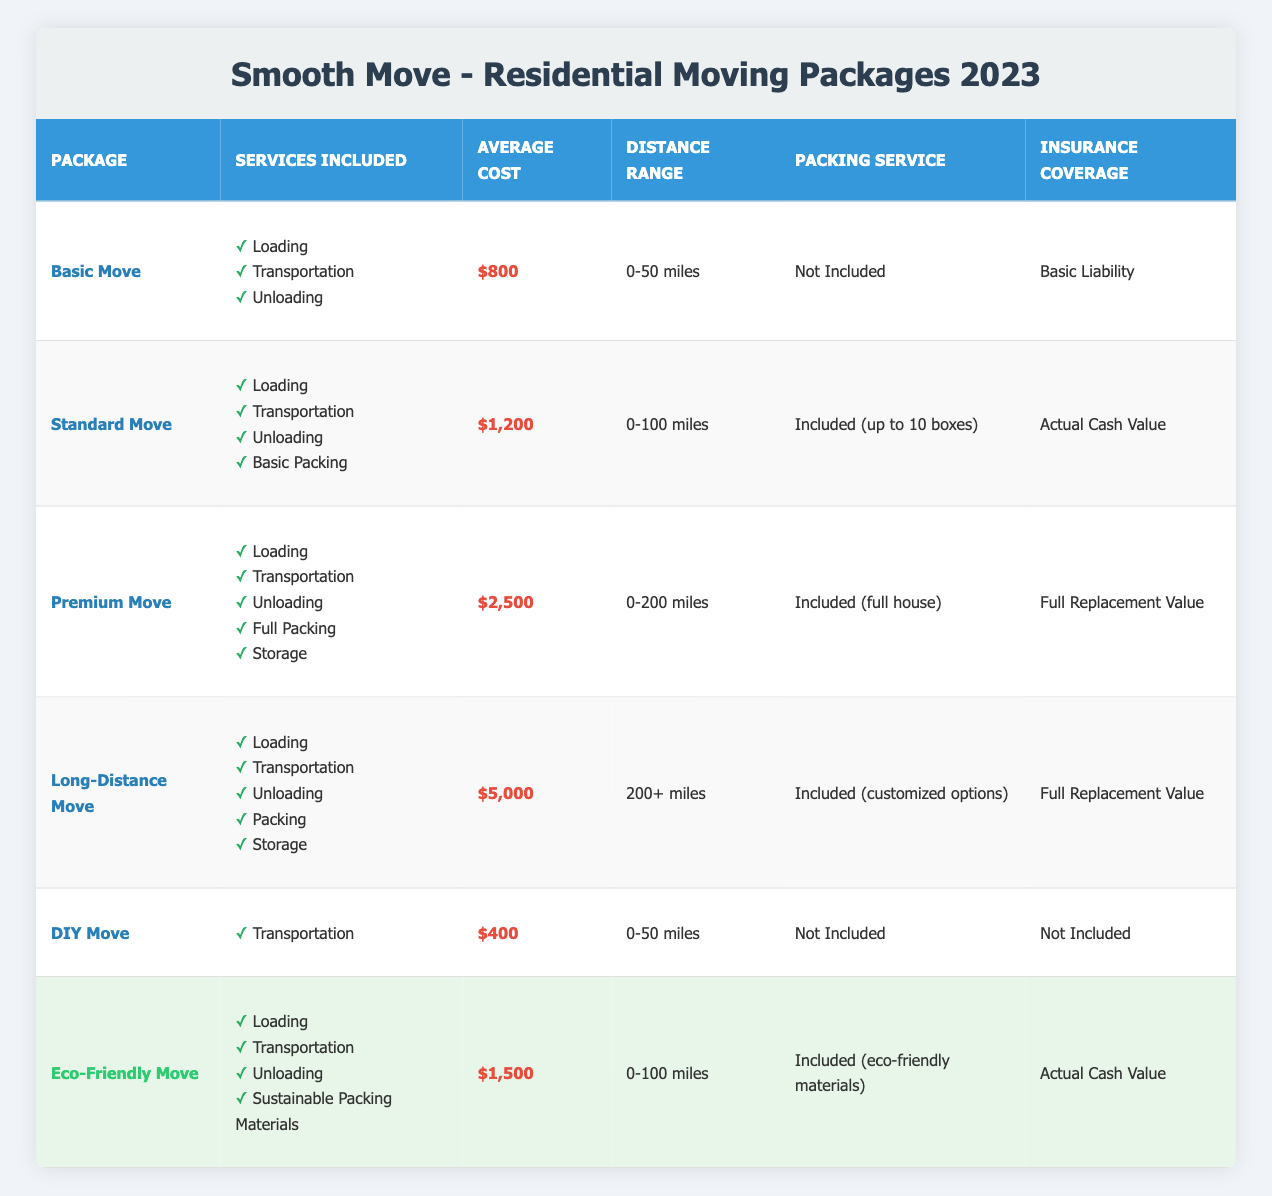What is the average cost of the Standard Move package? The average cost of the Standard Move package is listed in the table as $1,200.
Answer: $1,200 Which package offers full packing service? The Premium Move and Long-Distance Move packages both include full packing service, as indicated in the table.
Answer: Premium Move and Long-Distance Move Is insurance coverage included in the DIY Move package? The table specifies that the DIY Move package does not include any insurance coverage.
Answer: No What services are included in the Eco-Friendly Move package? The services included in the Eco-Friendly Move package are Loading, Transportation, Unloading, and Sustainable Packing Materials, as shown in the table.
Answer: Loading, Transportation, Unloading, Sustainable Packing Materials If a customer needs to move over 200 miles, which package is available? The only package available for a distance over 200 miles is the Long-Distance Move package, according to the distance range specified in the table.
Answer: Long-Distance Move How many packages include packing services? The packages that include packing services are Standard Move, Premium Move, Long-Distance Move, and Eco-Friendly Move. There are four such packages in total.
Answer: 4 What is the total average cost of the Basic Move and DIY Move packages? To find the total average cost of the Basic Move and DIY Move packages, add their average costs: $800 (Basic Move) + $400 (DIY Move) = $1,200. Therefore, the total average cost is $1,200.
Answer: $1,200 Is it true that the Premium Move package has the highest average cost? Yes, upon reviewing the average costs of all packages, the Premium Move package is listed with the highest average cost of $2,500.
Answer: Yes Which package has the longest distance range that includes packing services? Analyzing the distance ranges and the services provided, the Long-Distance Move package, which covers 200+ miles and includes customized packing options, has the longest distance range with packing services.
Answer: Long-Distance Move 